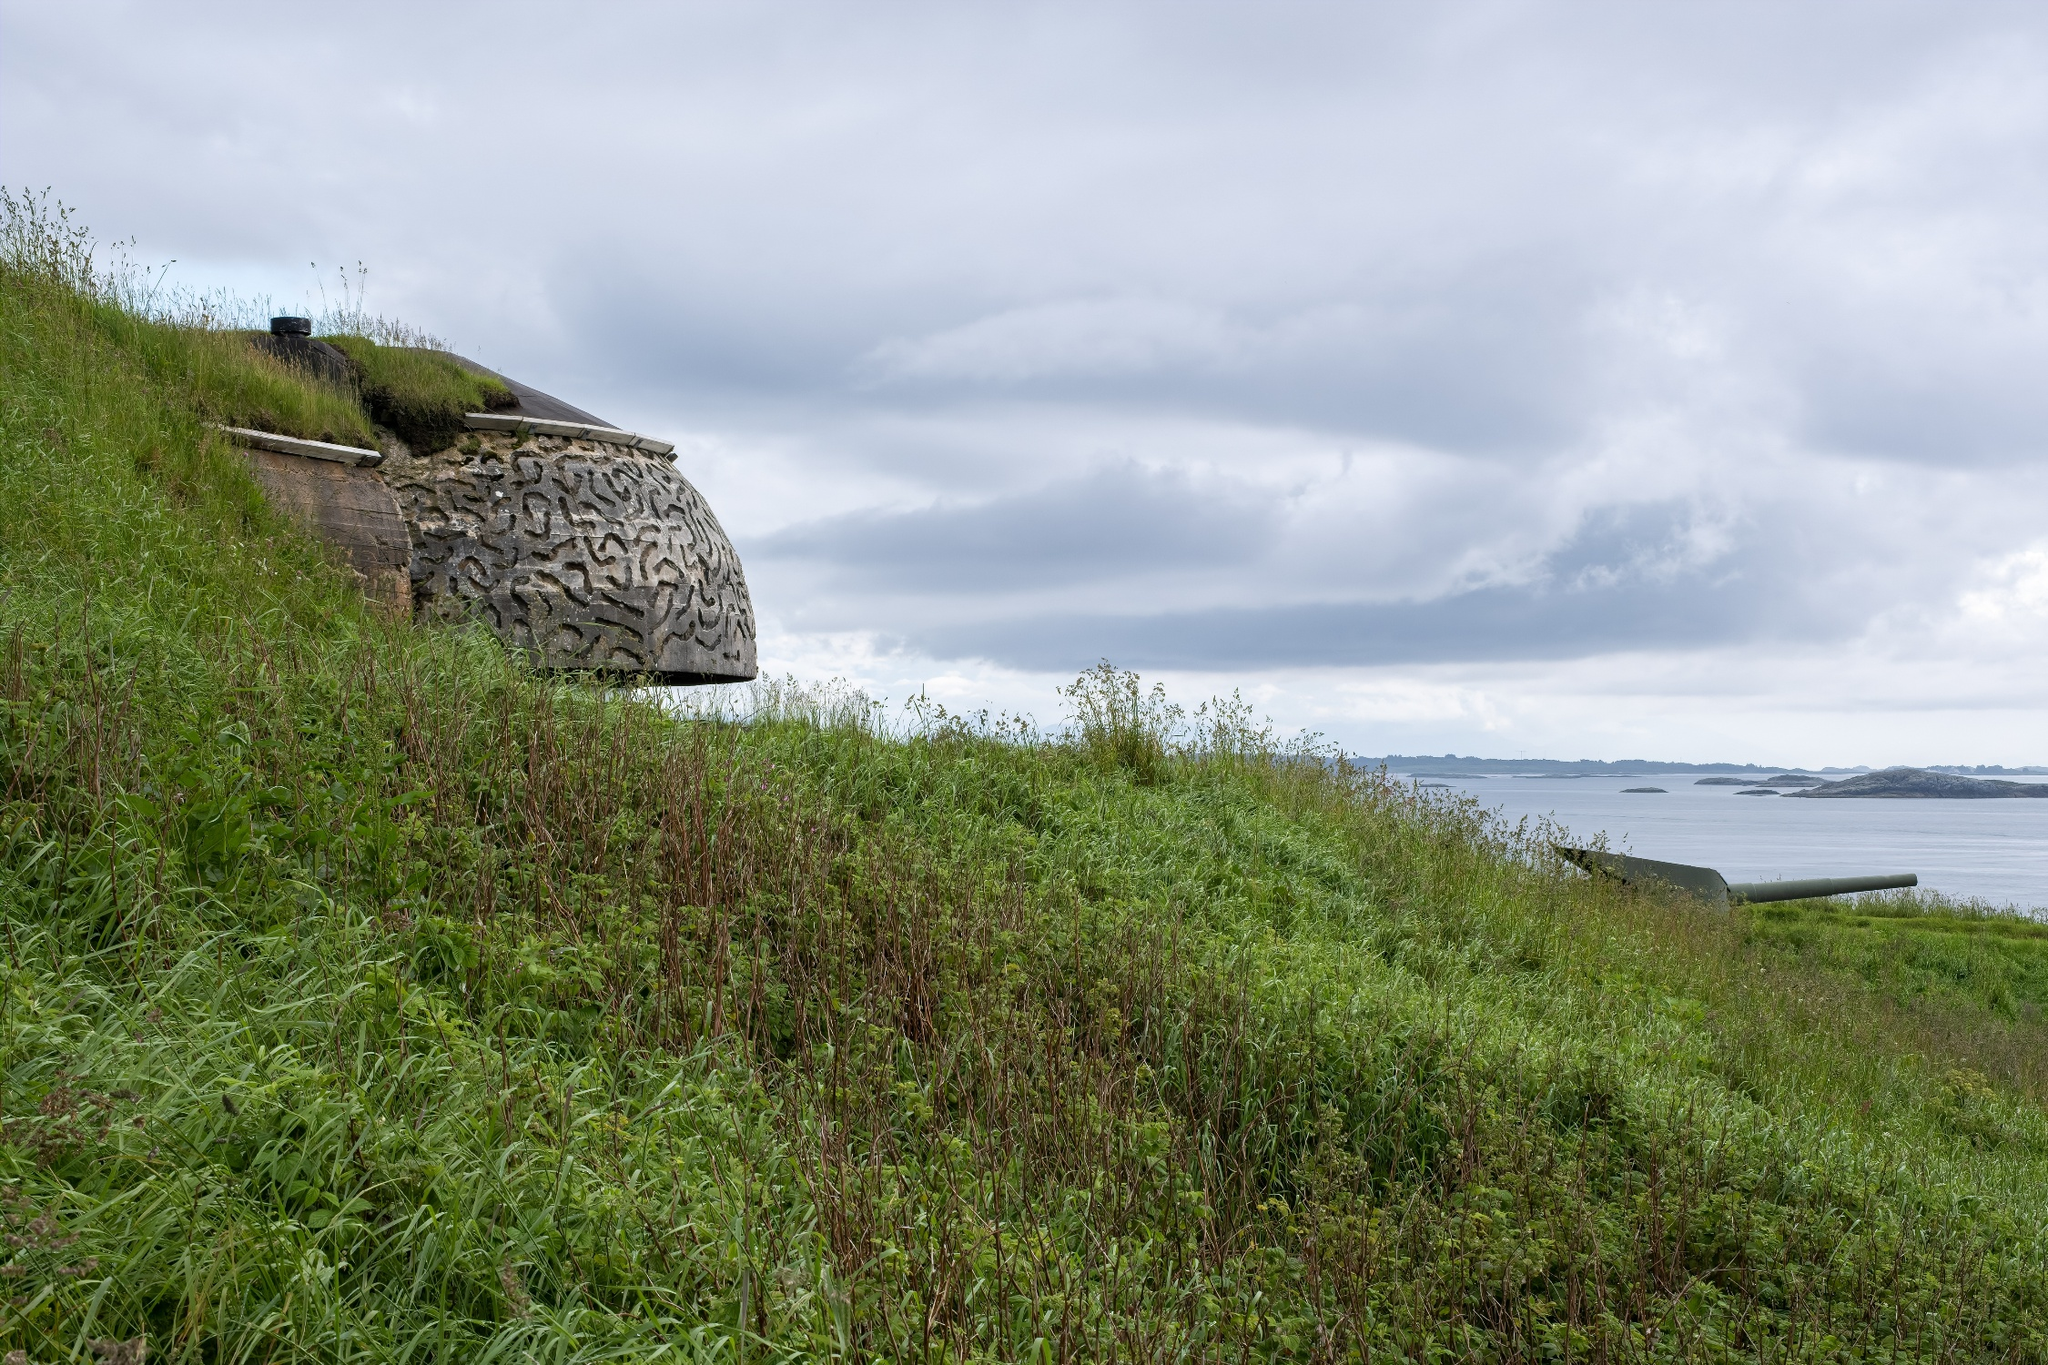Based on this image, describe a realistic scenario and another imaginative one. Realistic Scenario (Short):
A historian visits the site on a mild, overcast day, examining the stone bunker and taking notes for a research paper on coastal defenses used during World War II. The serene ocean and lush greenery frame the moment as the historian reflects on the passage of time.

Imaginative Scenario (Long):
An adventurous astrophysicist equipped with experimental quantum technology activates the stone bunker, revealing it as a covert research outpost. He steps inside, discovering a hidden laboratory with ancient yet advanced equipment. Surprisingly, the bunker is a focal point for time dilation research, and once activated, he finds himself oscillating between different time periods - witnessing the construction of the bunker, its use during the war, and even far-flung future epochs where humans have established contact with extraterrestrial civilizations. The ordinary bunker becomes a vessel of extraordinary exploration, revealing secrets of the past and possibilities of the future. 